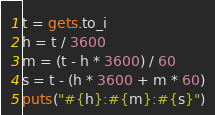Convert code to text. <code><loc_0><loc_0><loc_500><loc_500><_Ruby_>t = gets.to_i
h = t / 3600
m = (t - h * 3600) / 60
s = t - (h * 3600 + m * 60)
puts("#{h}:#{m}:#{s}")</code> 